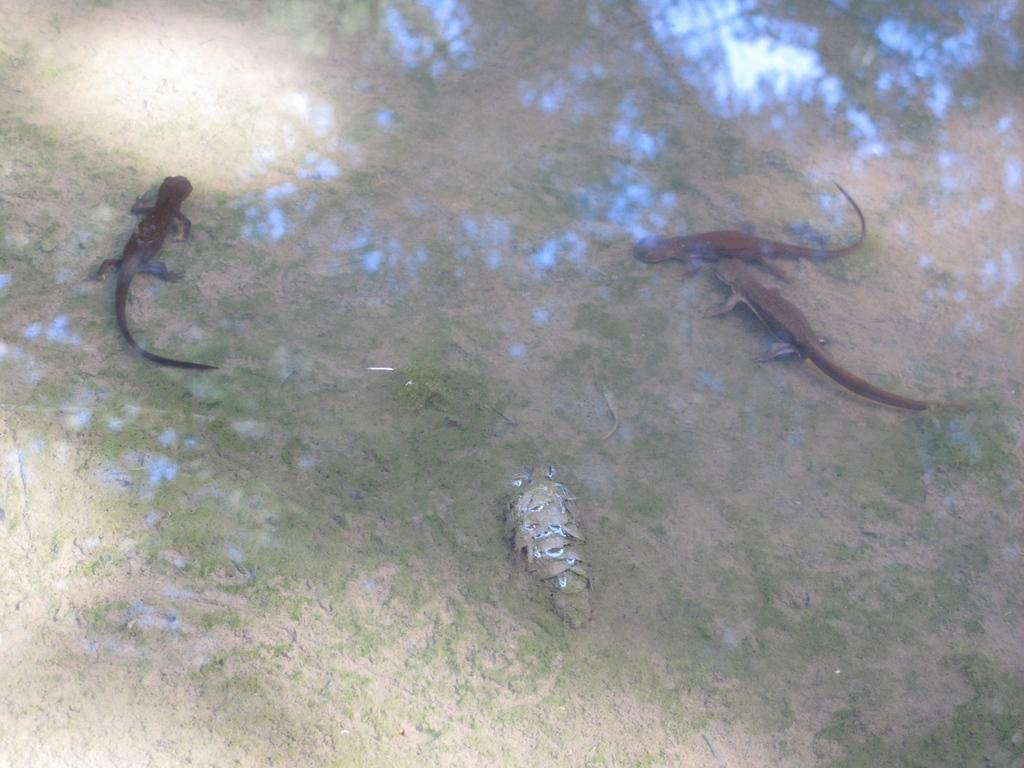What type of animals are on the ground in the image? There are reptiles on the ground in the image. What else can be seen in the image besides the reptiles? There is water visible in the image. How many bikes are parked near the reptiles in the image? There are no bikes present in the image; it only features reptiles and water. What type of design can be seen on the reptiles' spots in the image? There are no spots or designs mentioned on the reptiles in the image. 